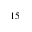<formula> <loc_0><loc_0><loc_500><loc_500>^ { 1 5 }</formula> 